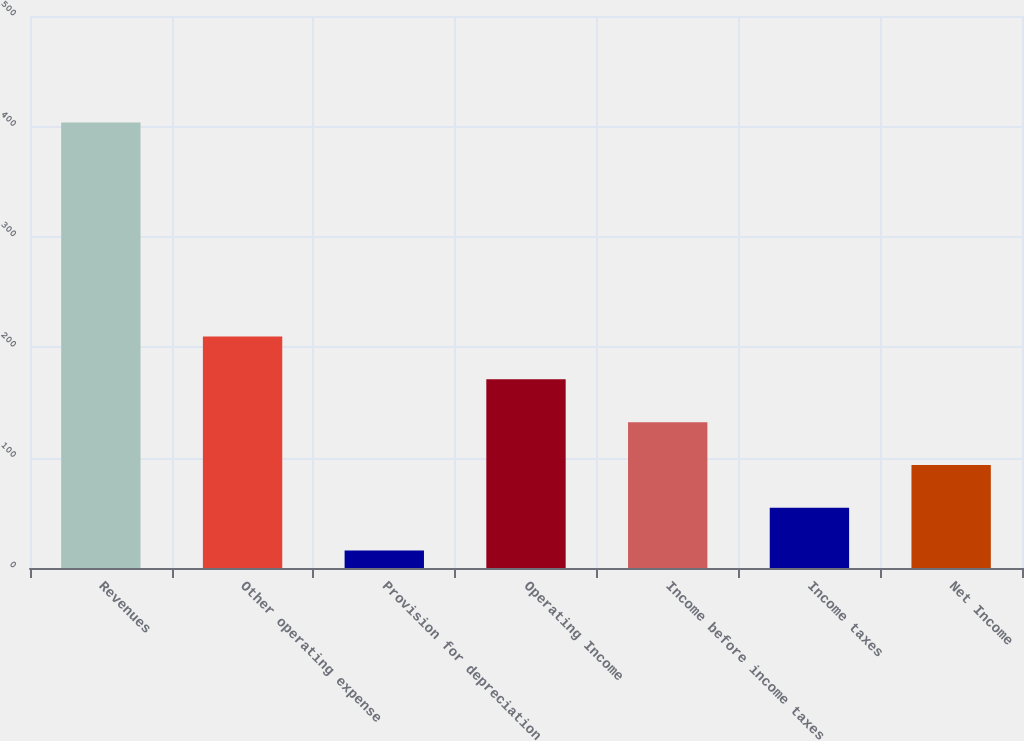<chart> <loc_0><loc_0><loc_500><loc_500><bar_chart><fcel>Revenues<fcel>Other operating expense<fcel>Provision for depreciation<fcel>Operating Income<fcel>Income before income taxes<fcel>Income taxes<fcel>Net Income<nl><fcel>403.5<fcel>209.65<fcel>15.8<fcel>170.88<fcel>132.11<fcel>54.57<fcel>93.34<nl></chart> 